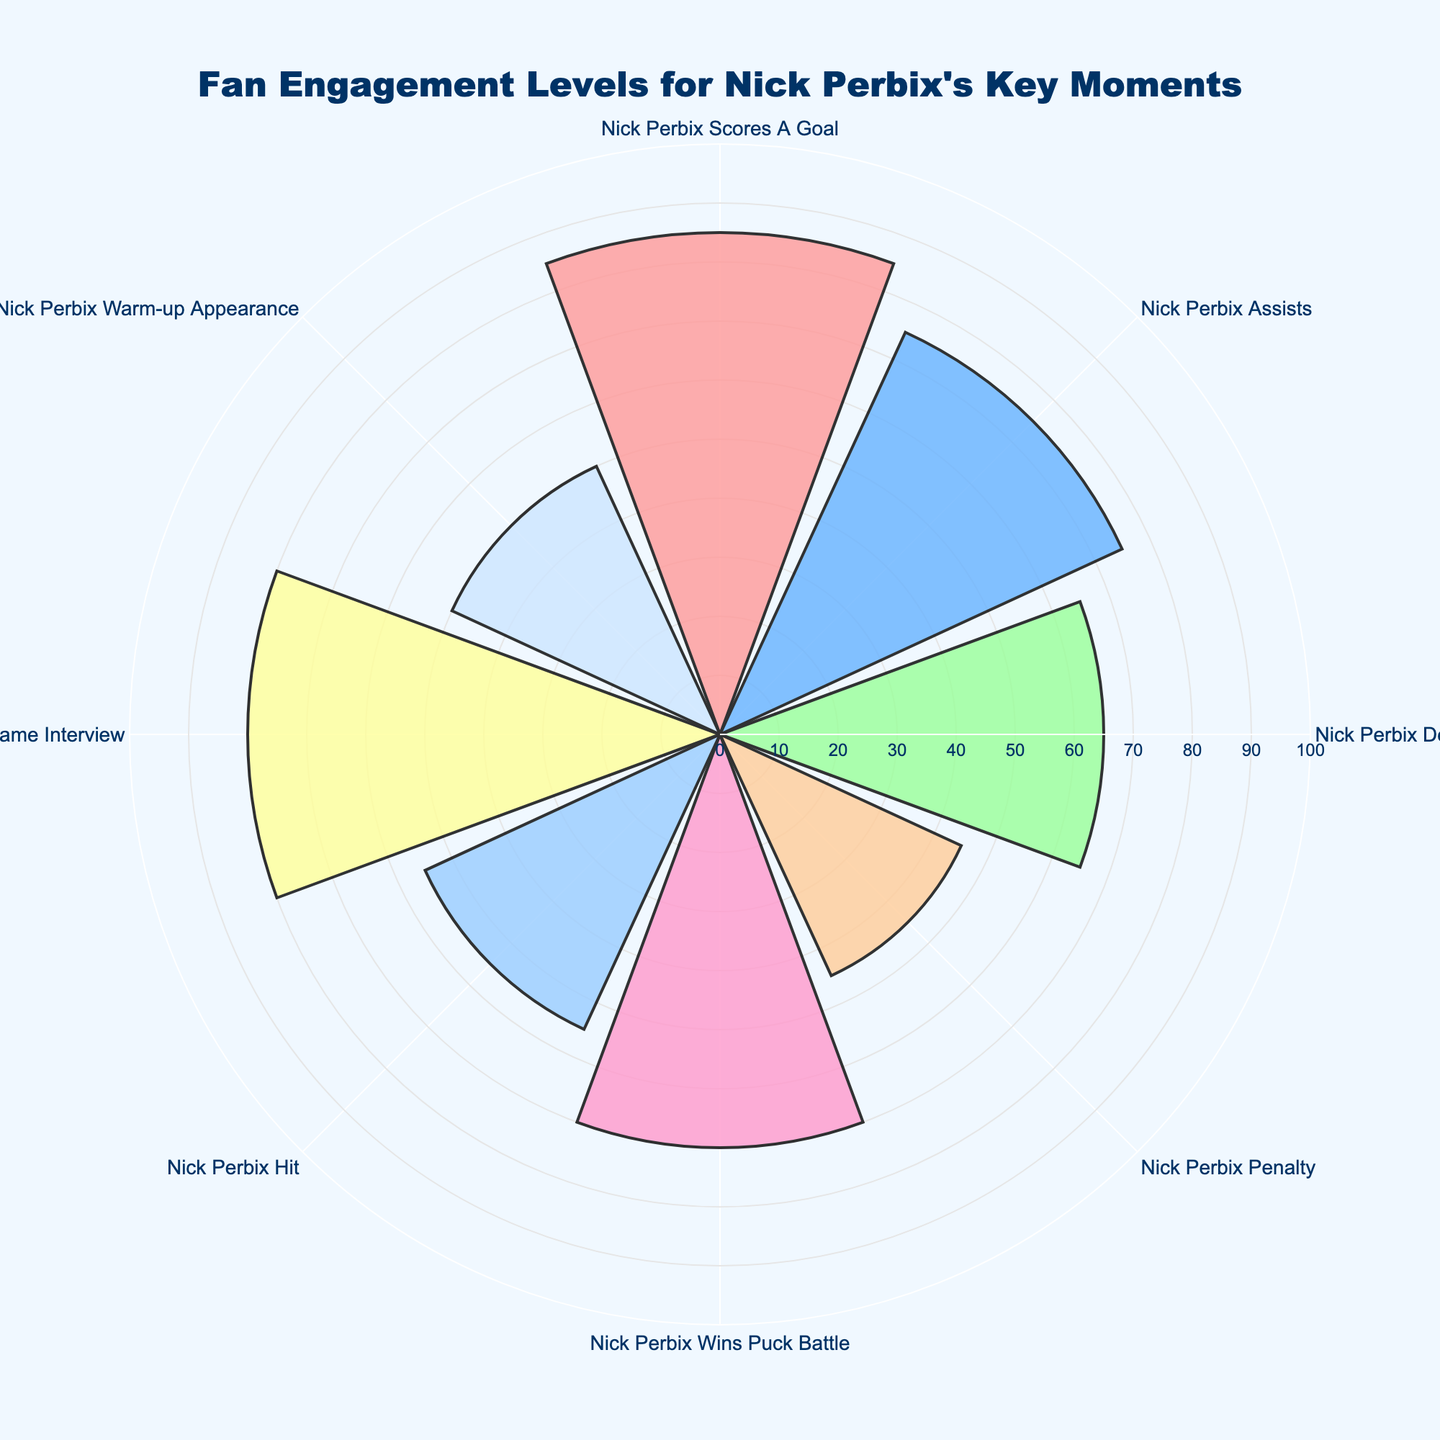what is the title of the chart? The title of the chart is displayed at the top of the figure in a larger font size and reads, "Fan Engagement Levels for Nick Perbix's Key Moments."
Answer: Fan Engagement Levels for Nick Perbix's Key Moments Is the engagement level higher for "Nick Perbix Scores A Goal" or "Nick Perbix Warm-up Appearance"? To compare the engagement levels between "Nick Perbix Scores A Goal" and "Nick Perbix Warm-up Appearance," look at the radial values for these events. "Nick Perbix Scores A Goal" has a higher engagement level (85) compared to "Nick Perbix Warm-up Appearance" (50).
Answer: Nick Perbix Scores A Goal Which event has the highest engagement level? To determine the highest engagement level, observe the event with the longest radial bar. The event "Nick Perbix Scores A Goal" has the highest engagement level of 85.
Answer: Nick Perbix Scores A Goal What is the average engagement level for all events? To find the average engagement level, sum all engagement levels and divide by the number of events: (85 + 75 + 65 + 45 + 70 + 55 + 80 + 50) / 8 = 66.875.
Answer: 66.875 How many events have an engagement level above 70? To determine the number of events with engagement levels above 70, count the events with radial values greater than 70. They are "Nick Perbix Scores A Goal" (85), "Nick Perbix Assists" (75), and "Nick Perbix Post-Game Interview" (80). There are 3 events.
Answer: 3 What's the difference in engagement levels between "Nick Perbix Defensive Block" and "Nick Perbix Penalty"? Calculate the difference by subtracting the engagement level of "Nick Perbix Penalty" from "Nick Perbix Defensive Block": 65 - 45 = 20.
Answer: 20 Do more events have engagement levels above or below 60? Count the events above 60: "Nick Perbix Scores A Goal" (85), "Nick Perbix Assists" (75), "Nick Perbix Defensive Block" (65), "Nick Perbix Wins Puck Battle" (70), "Nick Perbix Post-Game Interview" (80) - 5 events. Count the events below 60: "Nick Perbix Penalty" (45), "Nick Perbix Hit" (55), "Nick Perbix Warm-up Appearance" (50) - 3 events. More events are above 60.
Answer: Above 60 Which two events have engagement levels closest to each other? Find the two events with the smallest difference in engagement levels. "Nick Perbix Assists" (75) and "Nick Perbix Post-Game Interview" (80) have a difference of 5, which is the smallest.
Answer: Nick Perbix Assists and Nick Perbix Post-Game Interview How many unique colors are used in this chart to represent different events? The chart uses unique colors for each event, identifiable distinctly from one another. There are 8 different events, resulting in 8 unique colors used.
Answer: 8 